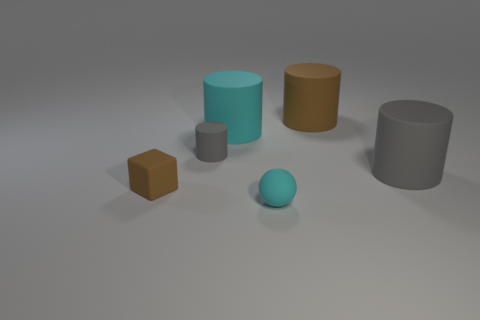Can you describe the shapes and colors of the objects in the image? The image features five objects with two distinct shapes. There are two cylinders and three cubes. In terms of color, there are two objects with a similar teal hue, two with different shades of brown, and one in gray. 